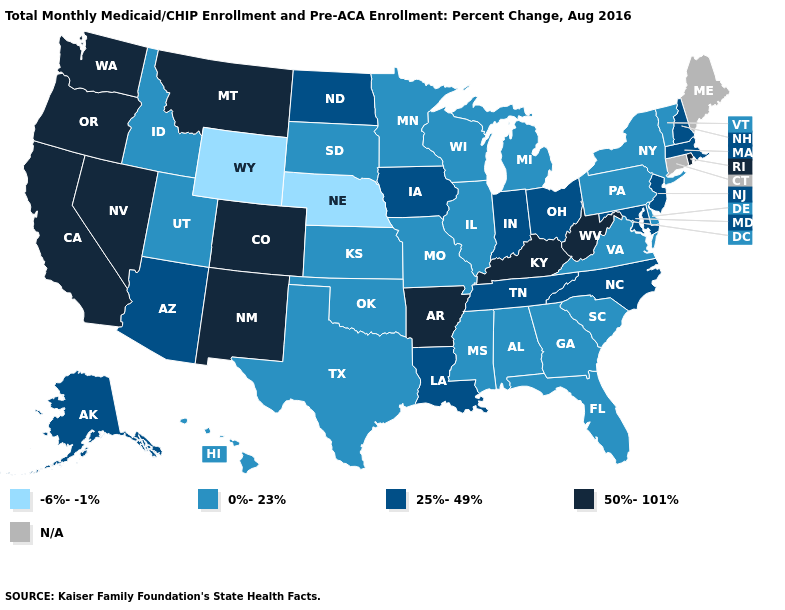What is the highest value in the USA?
Short answer required. 50%-101%. Name the states that have a value in the range N/A?
Concise answer only. Connecticut, Maine. Among the states that border Texas , which have the highest value?
Keep it brief. Arkansas, New Mexico. What is the value of Maryland?
Short answer required. 25%-49%. What is the value of New Mexico?
Concise answer only. 50%-101%. Does Alaska have the highest value in the West?
Short answer required. No. Does the map have missing data?
Keep it brief. Yes. Does North Dakota have the lowest value in the USA?
Keep it brief. No. Name the states that have a value in the range 25%-49%?
Short answer required. Alaska, Arizona, Indiana, Iowa, Louisiana, Maryland, Massachusetts, New Hampshire, New Jersey, North Carolina, North Dakota, Ohio, Tennessee. What is the value of Illinois?
Write a very short answer. 0%-23%. Name the states that have a value in the range N/A?
Be succinct. Connecticut, Maine. 